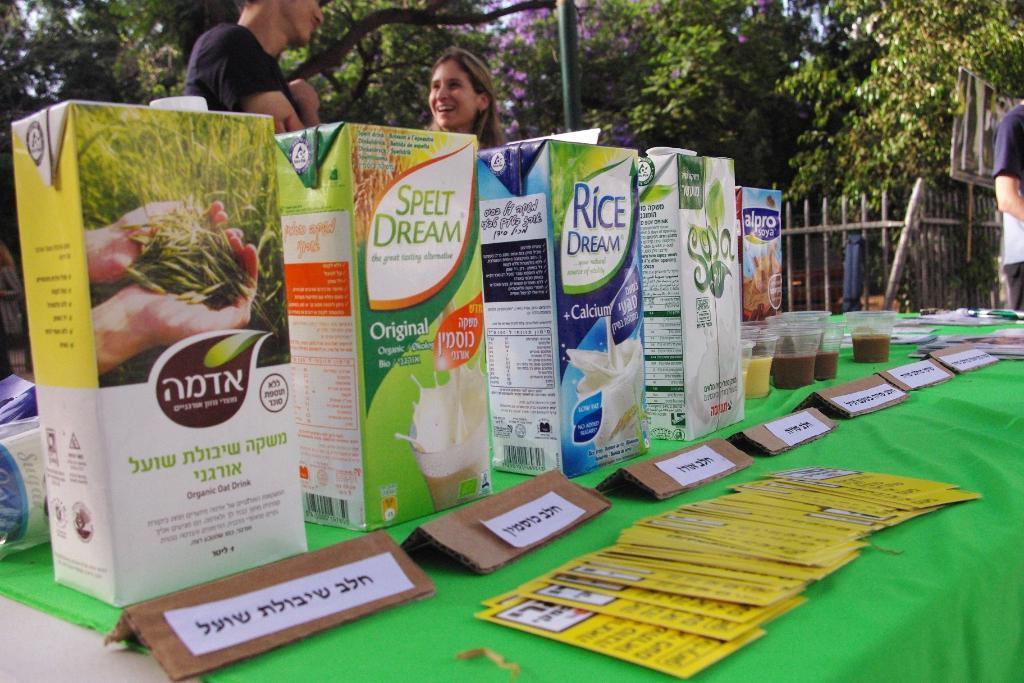Please provide a concise description of this image. In this image, we can see there are bottles, glasses, name boards, brochures and other objects arranged on a green colored cloth which is on a table. In the background, there are three persons, trees and a fence. 